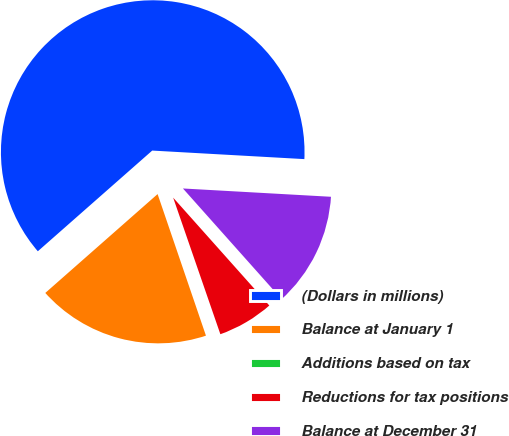Convert chart. <chart><loc_0><loc_0><loc_500><loc_500><pie_chart><fcel>(Dollars in millions)<fcel>Balance at January 1<fcel>Additions based on tax<fcel>Reductions for tax positions<fcel>Balance at December 31<nl><fcel>62.38%<fcel>18.75%<fcel>0.06%<fcel>6.29%<fcel>12.52%<nl></chart> 